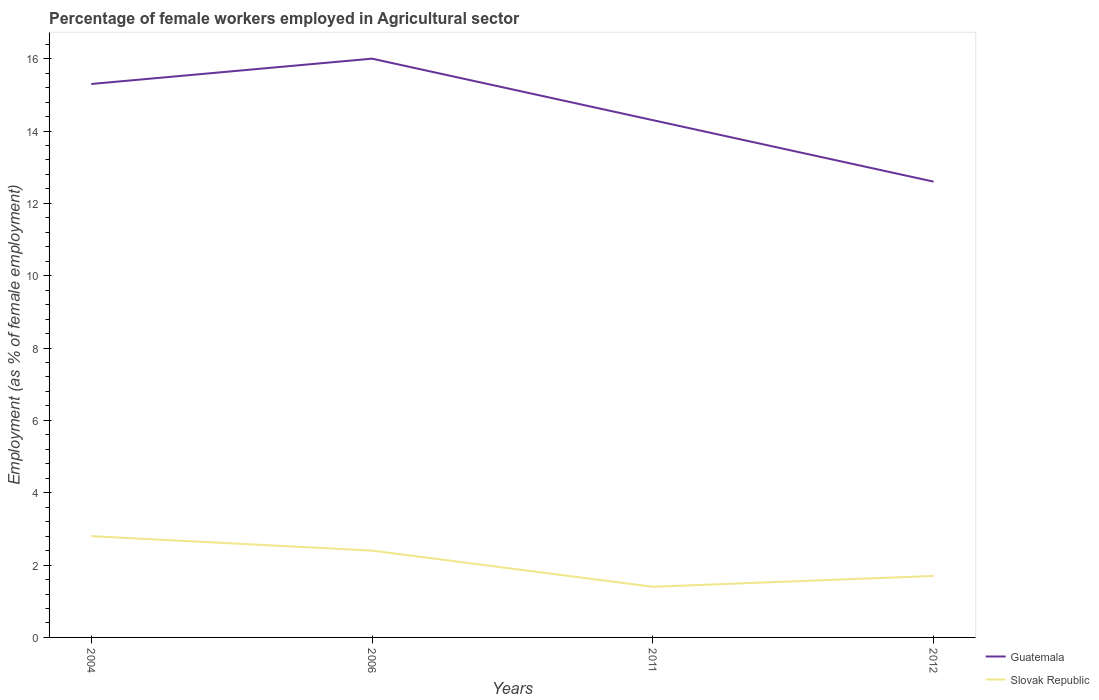Does the line corresponding to Slovak Republic intersect with the line corresponding to Guatemala?
Offer a terse response. No. Across all years, what is the maximum percentage of females employed in Agricultural sector in Guatemala?
Provide a short and direct response. 12.6. In which year was the percentage of females employed in Agricultural sector in Slovak Republic maximum?
Provide a succinct answer. 2011. What is the total percentage of females employed in Agricultural sector in Slovak Republic in the graph?
Offer a very short reply. 0.4. What is the difference between the highest and the second highest percentage of females employed in Agricultural sector in Slovak Republic?
Provide a succinct answer. 1.4. What is the difference between the highest and the lowest percentage of females employed in Agricultural sector in Slovak Republic?
Your answer should be compact. 2. Is the percentage of females employed in Agricultural sector in Guatemala strictly greater than the percentage of females employed in Agricultural sector in Slovak Republic over the years?
Offer a very short reply. No. How many lines are there?
Offer a terse response. 2. Are the values on the major ticks of Y-axis written in scientific E-notation?
Provide a short and direct response. No. Does the graph contain any zero values?
Offer a very short reply. No. Does the graph contain grids?
Your answer should be very brief. No. Where does the legend appear in the graph?
Give a very brief answer. Bottom right. How are the legend labels stacked?
Ensure brevity in your answer.  Vertical. What is the title of the graph?
Your answer should be compact. Percentage of female workers employed in Agricultural sector. Does "Jordan" appear as one of the legend labels in the graph?
Provide a short and direct response. No. What is the label or title of the X-axis?
Offer a terse response. Years. What is the label or title of the Y-axis?
Give a very brief answer. Employment (as % of female employment). What is the Employment (as % of female employment) of Guatemala in 2004?
Give a very brief answer. 15.3. What is the Employment (as % of female employment) in Slovak Republic in 2004?
Provide a succinct answer. 2.8. What is the Employment (as % of female employment) of Slovak Republic in 2006?
Give a very brief answer. 2.4. What is the Employment (as % of female employment) in Guatemala in 2011?
Provide a succinct answer. 14.3. What is the Employment (as % of female employment) in Slovak Republic in 2011?
Your response must be concise. 1.4. What is the Employment (as % of female employment) of Guatemala in 2012?
Ensure brevity in your answer.  12.6. What is the Employment (as % of female employment) in Slovak Republic in 2012?
Your response must be concise. 1.7. Across all years, what is the maximum Employment (as % of female employment) of Slovak Republic?
Keep it short and to the point. 2.8. Across all years, what is the minimum Employment (as % of female employment) in Guatemala?
Provide a succinct answer. 12.6. Across all years, what is the minimum Employment (as % of female employment) in Slovak Republic?
Give a very brief answer. 1.4. What is the total Employment (as % of female employment) in Guatemala in the graph?
Offer a terse response. 58.2. What is the difference between the Employment (as % of female employment) in Guatemala in 2004 and that in 2006?
Ensure brevity in your answer.  -0.7. What is the difference between the Employment (as % of female employment) in Slovak Republic in 2004 and that in 2006?
Your answer should be very brief. 0.4. What is the difference between the Employment (as % of female employment) of Guatemala in 2004 and that in 2011?
Make the answer very short. 1. What is the difference between the Employment (as % of female employment) of Guatemala in 2006 and that in 2011?
Offer a terse response. 1.7. What is the difference between the Employment (as % of female employment) in Slovak Republic in 2011 and that in 2012?
Offer a very short reply. -0.3. What is the difference between the Employment (as % of female employment) of Guatemala in 2004 and the Employment (as % of female employment) of Slovak Republic in 2006?
Your answer should be compact. 12.9. What is the difference between the Employment (as % of female employment) in Guatemala in 2004 and the Employment (as % of female employment) in Slovak Republic in 2012?
Your response must be concise. 13.6. What is the difference between the Employment (as % of female employment) in Guatemala in 2006 and the Employment (as % of female employment) in Slovak Republic in 2012?
Make the answer very short. 14.3. What is the average Employment (as % of female employment) of Guatemala per year?
Your answer should be compact. 14.55. What is the average Employment (as % of female employment) in Slovak Republic per year?
Make the answer very short. 2.08. What is the ratio of the Employment (as % of female employment) of Guatemala in 2004 to that in 2006?
Keep it short and to the point. 0.96. What is the ratio of the Employment (as % of female employment) in Guatemala in 2004 to that in 2011?
Offer a very short reply. 1.07. What is the ratio of the Employment (as % of female employment) in Guatemala in 2004 to that in 2012?
Offer a terse response. 1.21. What is the ratio of the Employment (as % of female employment) in Slovak Republic in 2004 to that in 2012?
Offer a terse response. 1.65. What is the ratio of the Employment (as % of female employment) in Guatemala in 2006 to that in 2011?
Ensure brevity in your answer.  1.12. What is the ratio of the Employment (as % of female employment) of Slovak Republic in 2006 to that in 2011?
Offer a terse response. 1.71. What is the ratio of the Employment (as % of female employment) in Guatemala in 2006 to that in 2012?
Offer a terse response. 1.27. What is the ratio of the Employment (as % of female employment) in Slovak Republic in 2006 to that in 2012?
Give a very brief answer. 1.41. What is the ratio of the Employment (as % of female employment) in Guatemala in 2011 to that in 2012?
Keep it short and to the point. 1.13. What is the ratio of the Employment (as % of female employment) in Slovak Republic in 2011 to that in 2012?
Your answer should be compact. 0.82. What is the difference between the highest and the second highest Employment (as % of female employment) of Guatemala?
Give a very brief answer. 0.7. 